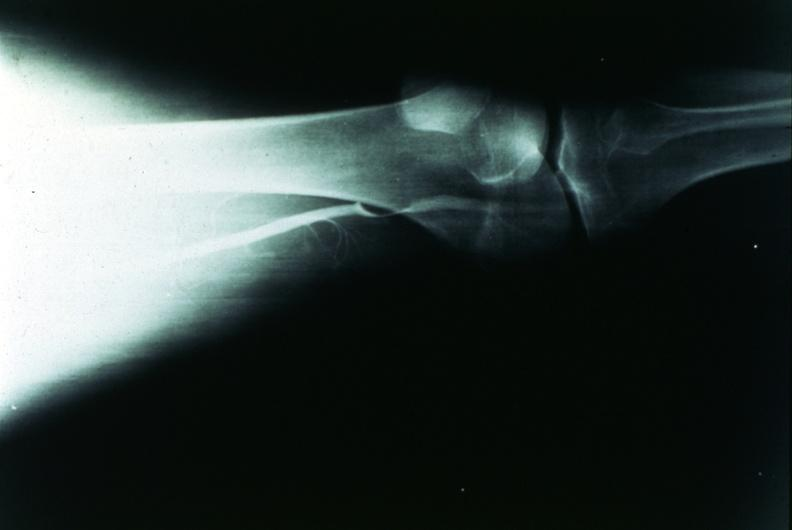does other x-rays show popliteal cyst?
Answer the question using a single word or phrase. No 